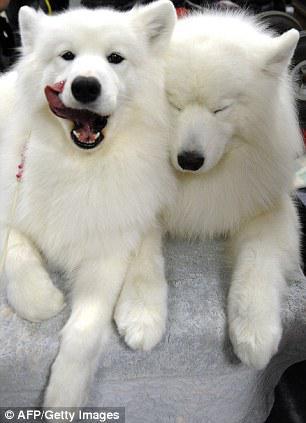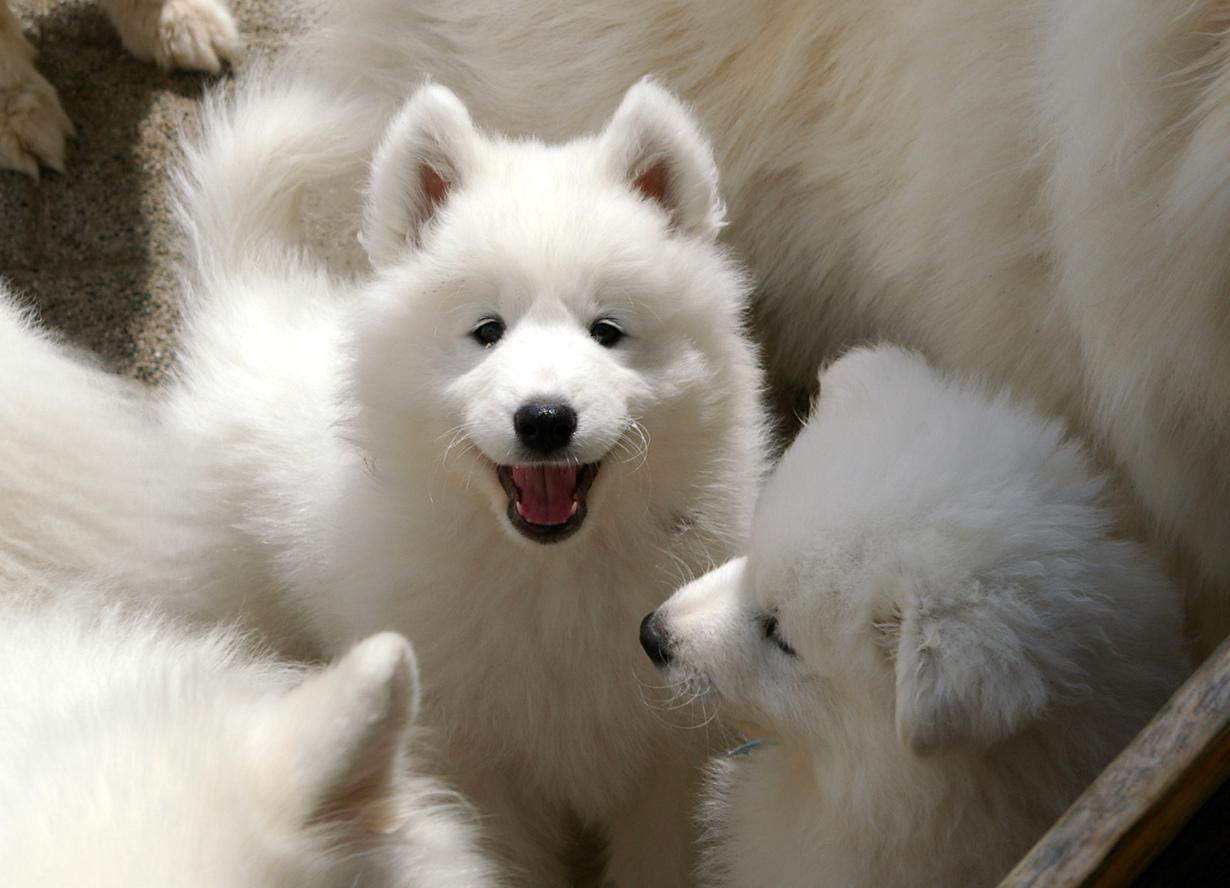The first image is the image on the left, the second image is the image on the right. For the images displayed, is the sentence "An image includes a reclining white dog with both eyes shut." factually correct? Answer yes or no. Yes. The first image is the image on the left, the second image is the image on the right. Considering the images on both sides, is "The dog's tongue is sticking out in at least one of the images." valid? Answer yes or no. Yes. 